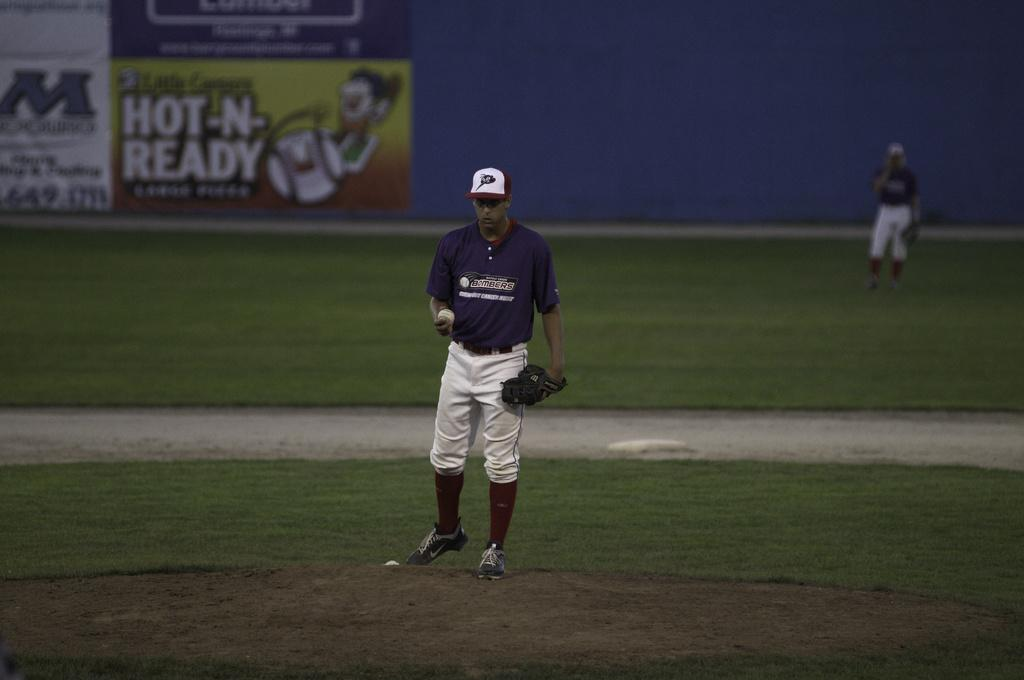<image>
Create a compact narrative representing the image presented. a Bombers player gets ready to pitch the ball 